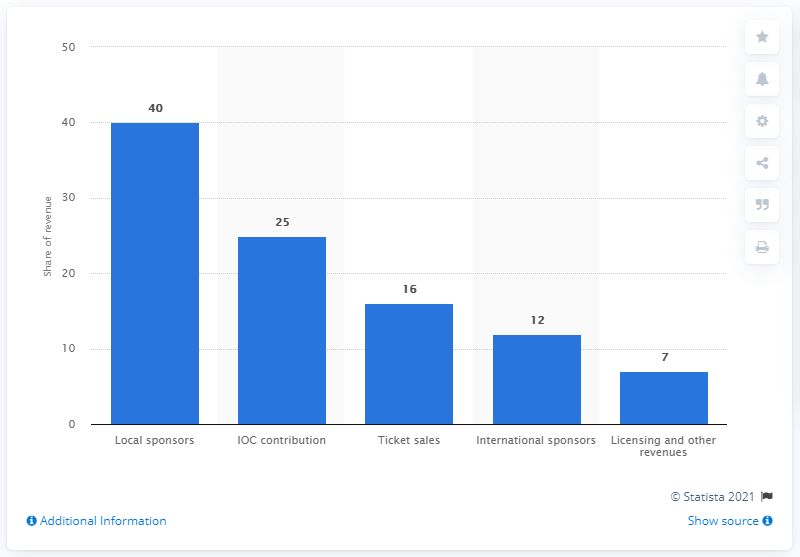Point out several critical features in this image. Rio's revenue is primarily generated by local sponsors, with a percentage of 40.. 